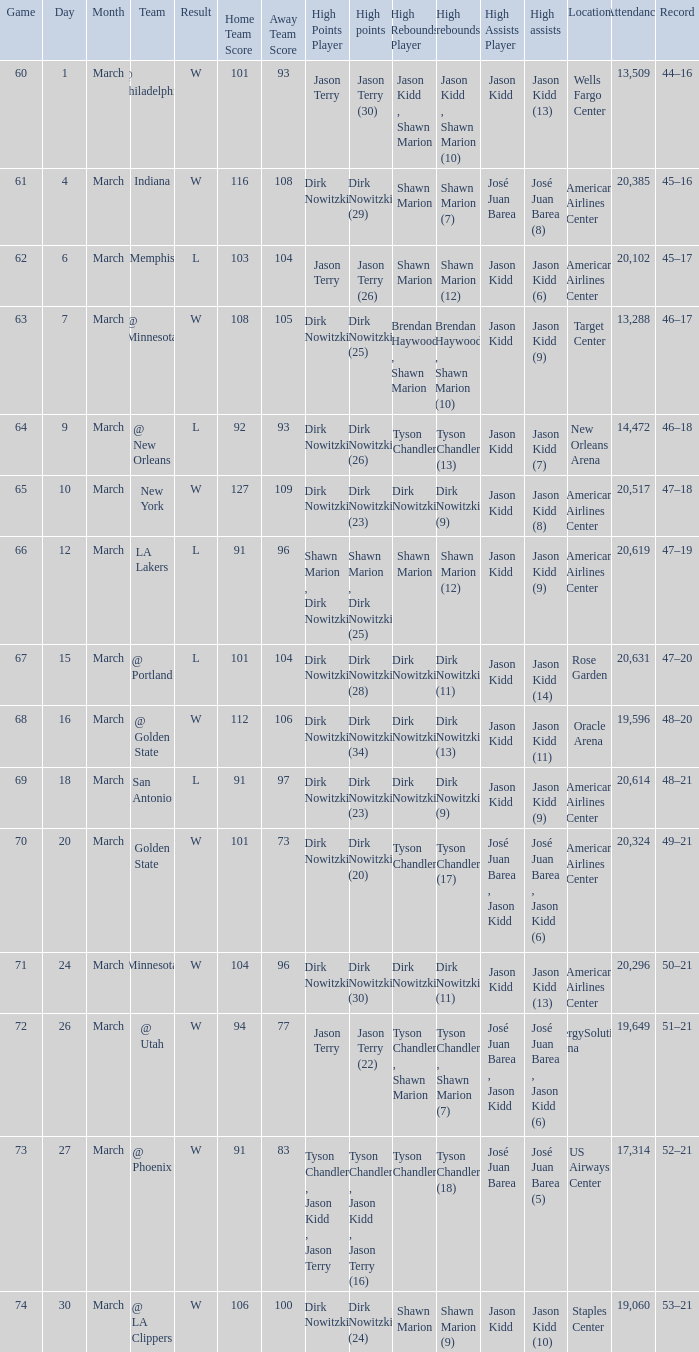I'm looking to parse the entire table for insights. Could you assist me with that? {'header': ['Game', 'Day', 'Month', 'Team', 'Result', 'Home Team Score', 'Away Team Score', 'High Points Player', 'High points', 'High Rebounds Player', 'High rebounds', 'High Assists Player', 'High assists', 'Location', 'Attendance', 'Record'], 'rows': [['60', '1', 'March', '@ Philadelphia', 'W', '101', '93', 'Jason Terry', 'Jason Terry (30)', 'Jason Kidd , Shawn Marion', 'Jason Kidd , Shawn Marion (10)', 'Jason Kidd', 'Jason Kidd (13)', 'Wells Fargo Center', '13,509', '44–16'], ['61', '4', 'March', 'Indiana', 'W', '116', '108', 'Dirk Nowitzki', 'Dirk Nowitzki (29)', 'Shawn Marion', 'Shawn Marion (7)', 'José Juan Barea', 'José Juan Barea (8)', 'American Airlines Center', '20,385', '45–16'], ['62', '6', 'March', 'Memphis', 'L', '103', '104', 'Jason Terry', 'Jason Terry (26)', 'Shawn Marion', 'Shawn Marion (12)', 'Jason Kidd', 'Jason Kidd (6)', 'American Airlines Center', '20,102', '45–17'], ['63', '7', 'March', '@ Minnesota', 'W', '108', '105', 'Dirk Nowitzki', 'Dirk Nowitzki (25)', 'Brendan Haywood , Shawn Marion', 'Brendan Haywood , Shawn Marion (10)', 'Jason Kidd', 'Jason Kidd (9)', 'Target Center', '13,288', '46–17'], ['64', '9', 'March', '@ New Orleans', 'L', '92', '93', 'Dirk Nowitzki', 'Dirk Nowitzki (26)', 'Tyson Chandler', 'Tyson Chandler (13)', 'Jason Kidd', 'Jason Kidd (7)', 'New Orleans Arena', '14,472', '46–18'], ['65', '10', 'March', 'New York', 'W', '127', '109', 'Dirk Nowitzki', 'Dirk Nowitzki (23)', 'Dirk Nowitzki', 'Dirk Nowitzki (9)', 'Jason Kidd', 'Jason Kidd (8)', 'American Airlines Center', '20,517', '47–18'], ['66', '12', 'March', 'LA Lakers', 'L', '91', '96', 'Shawn Marion , Dirk Nowitzki', 'Shawn Marion , Dirk Nowitzki (25)', 'Shawn Marion', 'Shawn Marion (12)', 'Jason Kidd', 'Jason Kidd (9)', 'American Airlines Center', '20,619', '47–19'], ['67', '15', 'March', '@ Portland', 'L', '101', '104', 'Dirk Nowitzki', 'Dirk Nowitzki (28)', 'Dirk Nowitzki', 'Dirk Nowitzki (11)', 'Jason Kidd', 'Jason Kidd (14)', 'Rose Garden', '20,631', '47–20'], ['68', '16', 'March', '@ Golden State', 'W', '112', '106', 'Dirk Nowitzki', 'Dirk Nowitzki (34)', 'Dirk Nowitzki', 'Dirk Nowitzki (13)', 'Jason Kidd', 'Jason Kidd (11)', 'Oracle Arena', '19,596', '48–20'], ['69', '18', 'March', 'San Antonio', 'L', '91', '97', 'Dirk Nowitzki', 'Dirk Nowitzki (23)', 'Dirk Nowitzki', 'Dirk Nowitzki (9)', 'Jason Kidd', 'Jason Kidd (9)', 'American Airlines Center', '20,614', '48–21'], ['70', '20', 'March', 'Golden State', 'W', '101', '73', 'Dirk Nowitzki', 'Dirk Nowitzki (20)', 'Tyson Chandler', 'Tyson Chandler (17)', 'José Juan Barea , Jason Kidd', 'José Juan Barea , Jason Kidd (6)', 'American Airlines Center', '20,324', '49–21'], ['71', '24', 'March', 'Minnesota', 'W', '104', '96', 'Dirk Nowitzki', 'Dirk Nowitzki (30)', 'Dirk Nowitzki', 'Dirk Nowitzki (11)', 'Jason Kidd', 'Jason Kidd (13)', 'American Airlines Center', '20,296', '50–21'], ['72', '26', 'March', '@ Utah', 'W', '94', '77', 'Jason Terry', 'Jason Terry (22)', 'Tyson Chandler , Shawn Marion', 'Tyson Chandler , Shawn Marion (7)', 'José Juan Barea , Jason Kidd', 'José Juan Barea , Jason Kidd (6)', 'EnergySolutions Arena', '19,649', '51–21'], ['73', '27', 'March', '@ Phoenix', 'W', '91', '83', 'Tyson Chandler , Jason Kidd , Jason Terry', 'Tyson Chandler , Jason Kidd , Jason Terry (16)', 'Tyson Chandler', 'Tyson Chandler (18)', 'José Juan Barea', 'José Juan Barea (5)', 'US Airways Center', '17,314', '52–21'], ['74', '30', 'March', '@ LA Clippers', 'W', '106', '100', 'Dirk Nowitzki', 'Dirk Nowitzki (24)', 'Shawn Marion', 'Shawn Marion (9)', 'Jason Kidd', 'Jason Kidd (10)', 'Staples Center', '19,060', '53–21']]} Name the high points for march 30 Dirk Nowitzki (24). 